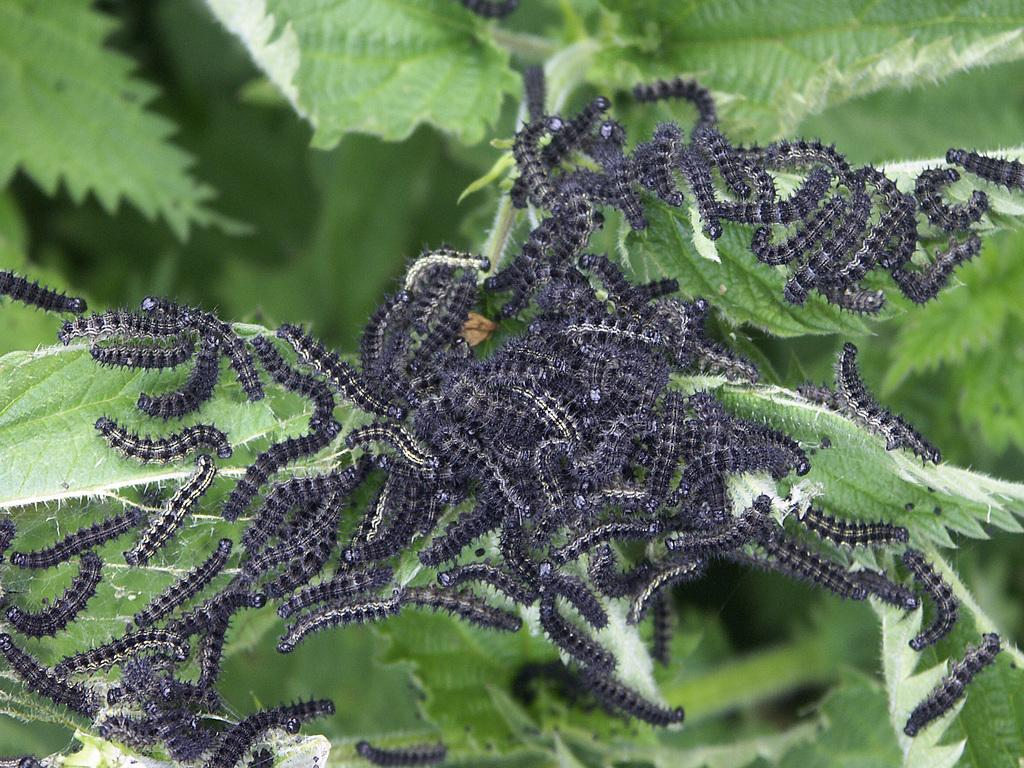What type of creatures can be seen in the image? There is a group of insects in the image. Where are the insects located? The insects are on the leaves. What type of fiction book is being read by the ducks in the image? There are no ducks or books present in the image; it features a group of insects on the leaves. 